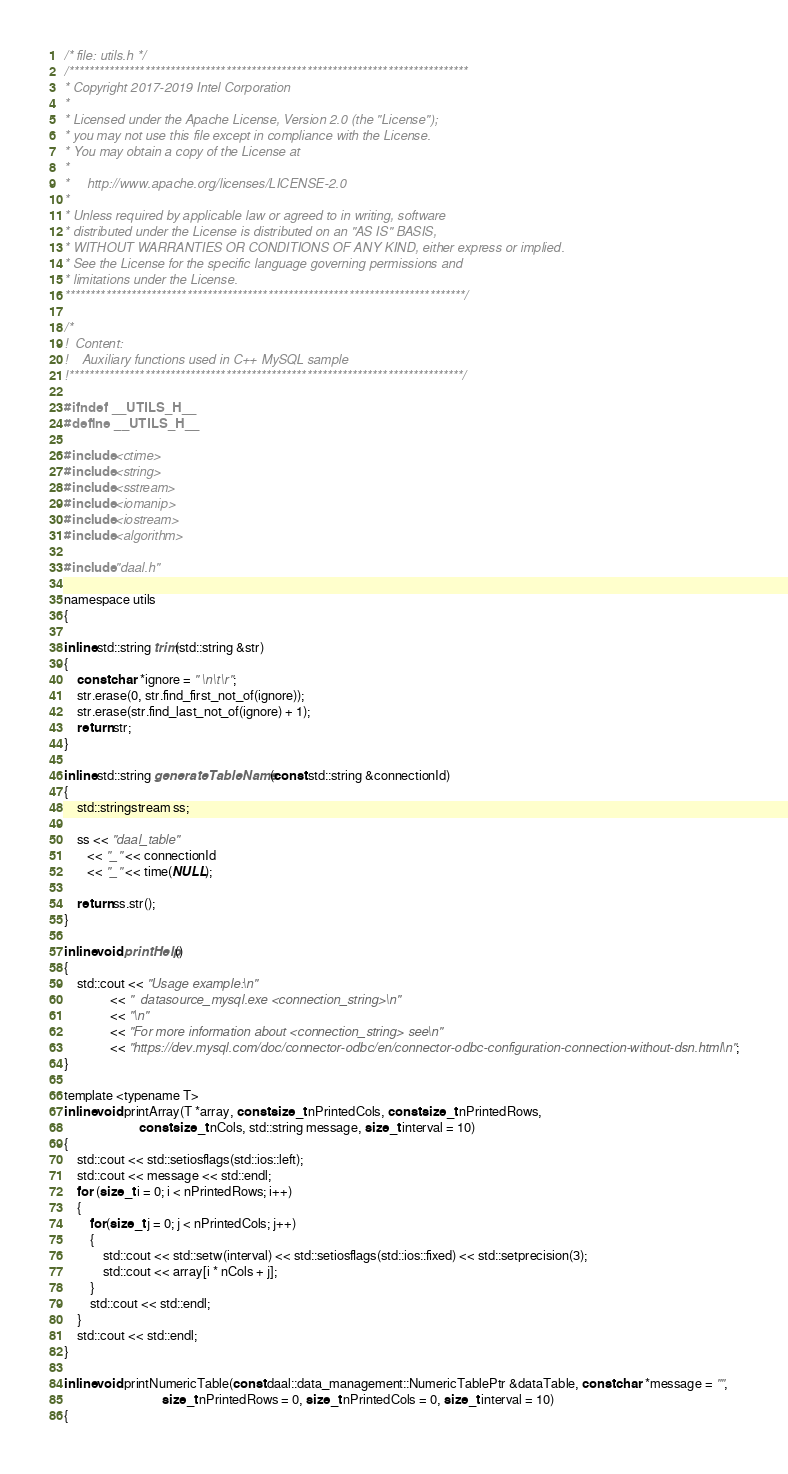<code> <loc_0><loc_0><loc_500><loc_500><_C_>/* file: utils.h */
/*******************************************************************************
* Copyright 2017-2019 Intel Corporation
*
* Licensed under the Apache License, Version 2.0 (the "License");
* you may not use this file except in compliance with the License.
* You may obtain a copy of the License at
*
*     http://www.apache.org/licenses/LICENSE-2.0
*
* Unless required by applicable law or agreed to in writing, software
* distributed under the License is distributed on an "AS IS" BASIS,
* WITHOUT WARRANTIES OR CONDITIONS OF ANY KIND, either express or implied.
* See the License for the specific language governing permissions and
* limitations under the License.
*******************************************************************************/

/*
!  Content:
!    Auxiliary functions used in C++ MySQL sample
!******************************************************************************/

#ifndef __UTILS_H__
#define __UTILS_H__

#include <ctime>
#include <string>
#include <sstream>
#include <iomanip>
#include <iostream>
#include <algorithm>

#include "daal.h"

namespace utils
{

inline std::string trim(std::string &str)
{
    const char *ignore = " \n\t\r";
    str.erase(0, str.find_first_not_of(ignore));
    str.erase(str.find_last_not_of(ignore) + 1);
    return str;
}

inline std::string generateTableName(const std::string &connectionId)
{
    std::stringstream ss;

    ss << "daal_table"
       << "_" << connectionId
       << "_" << time(NULL);

    return ss.str();
}

inline void printHelp()
{
    std::cout << "Usage example:\n"
              << "  datasource_mysql.exe <connection_string>\n"
              << "\n"
              << "For more information about <connection_string> see\n"
              << "https://dev.mysql.com/doc/connector-odbc/en/connector-odbc-configuration-connection-without-dsn.html\n";
}

template <typename T>
inline void printArray(T *array, const size_t nPrintedCols, const size_t nPrintedRows,
                       const size_t nCols, std::string message, size_t interval = 10)
{
    std::cout << std::setiosflags(std::ios::left);
    std::cout << message << std::endl;
    for (size_t i = 0; i < nPrintedRows; i++)
    {
        for(size_t j = 0; j < nPrintedCols; j++)
        {
            std::cout << std::setw(interval) << std::setiosflags(std::ios::fixed) << std::setprecision(3);
            std::cout << array[i * nCols + j];
        }
        std::cout << std::endl;
    }
    std::cout << std::endl;
}

inline void printNumericTable(const daal::data_management::NumericTablePtr &dataTable, const char *message = "",
                              size_t nPrintedRows = 0, size_t nPrintedCols = 0, size_t interval = 10)
{</code> 